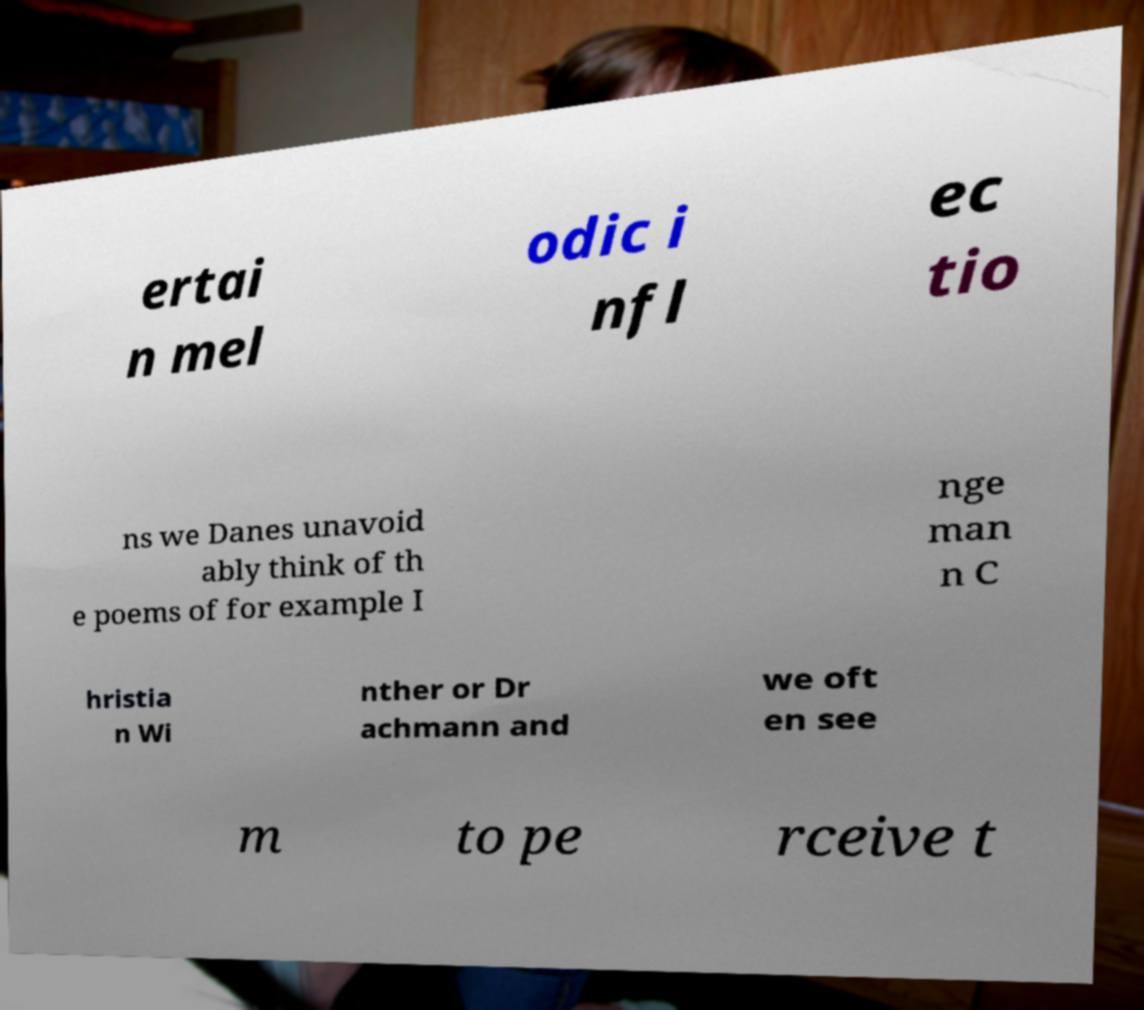Could you assist in decoding the text presented in this image and type it out clearly? ertai n mel odic i nfl ec tio ns we Danes unavoid ably think of th e poems of for example I nge man n C hristia n Wi nther or Dr achmann and we oft en see m to pe rceive t 